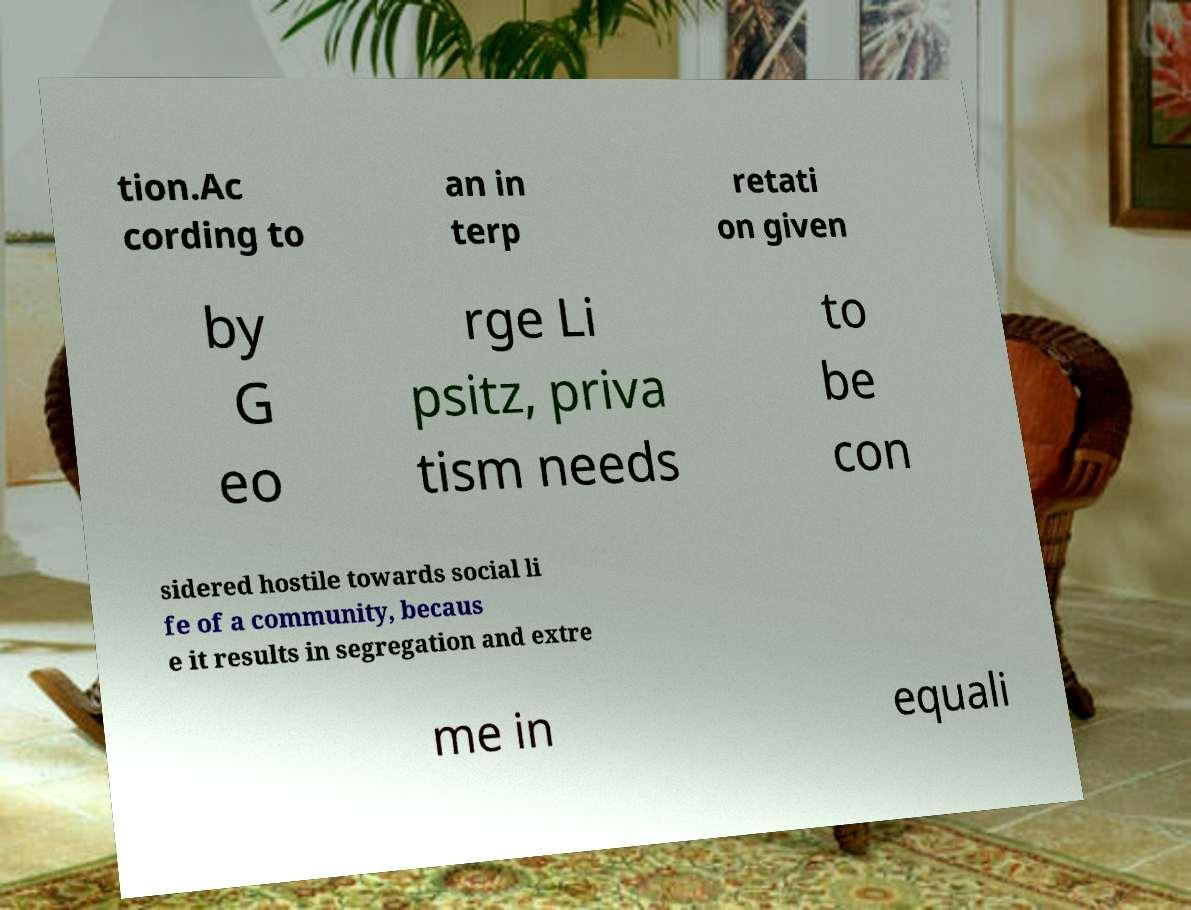Please read and relay the text visible in this image. What does it say? tion.Ac cording to an in terp retati on given by G eo rge Li psitz, priva tism needs to be con sidered hostile towards social li fe of a community, becaus e it results in segregation and extre me in equali 